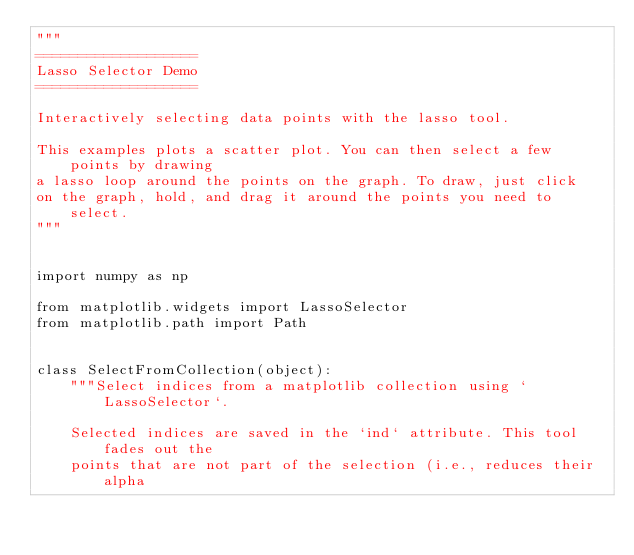<code> <loc_0><loc_0><loc_500><loc_500><_Python_>"""
===================
Lasso Selector Demo
===================

Interactively selecting data points with the lasso tool.

This examples plots a scatter plot. You can then select a few points by drawing
a lasso loop around the points on the graph. To draw, just click
on the graph, hold, and drag it around the points you need to select.
"""


import numpy as np

from matplotlib.widgets import LassoSelector
from matplotlib.path import Path


class SelectFromCollection(object):
    """Select indices from a matplotlib collection using `LassoSelector`.

    Selected indices are saved in the `ind` attribute. This tool fades out the
    points that are not part of the selection (i.e., reduces their alpha</code> 